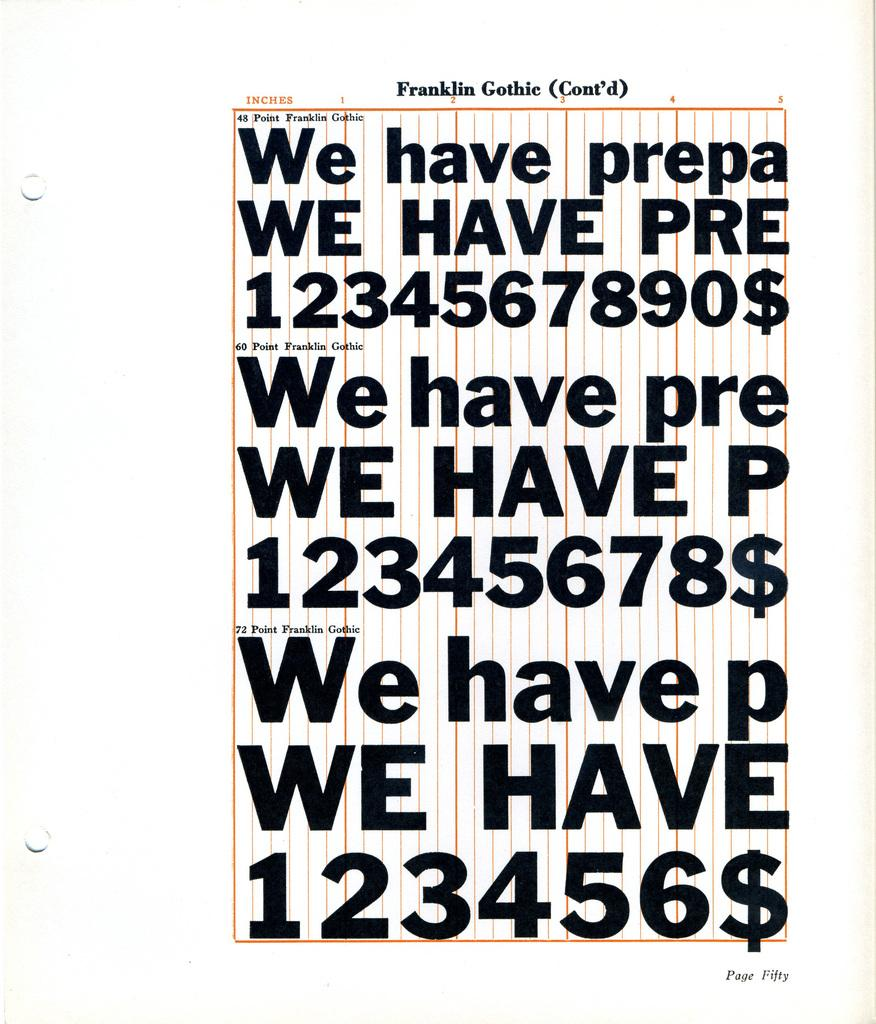<image>
Create a compact narrative representing the image presented. A page displays examples of Franklin Gothic font in different sizes. 